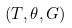Convert formula to latex. <formula><loc_0><loc_0><loc_500><loc_500>( T , \theta , G )</formula> 